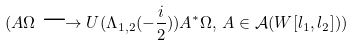<formula> <loc_0><loc_0><loc_500><loc_500>( A \Omega \longrightarrow U ( \Lambda _ { 1 , 2 } ( - \frac { i } { 2 } ) ) A ^ { * } \Omega , \, A \in \mathcal { A } ( W [ l _ { 1 } , l _ { 2 } ] ) )</formula> 